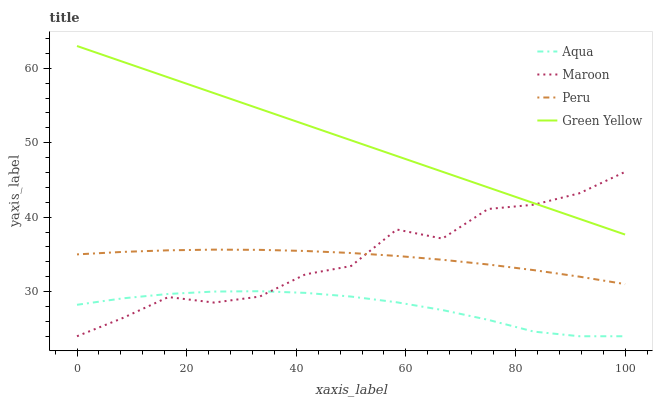Does Aqua have the minimum area under the curve?
Answer yes or no. Yes. Does Green Yellow have the maximum area under the curve?
Answer yes or no. Yes. Does Peru have the minimum area under the curve?
Answer yes or no. No. Does Peru have the maximum area under the curve?
Answer yes or no. No. Is Green Yellow the smoothest?
Answer yes or no. Yes. Is Maroon the roughest?
Answer yes or no. Yes. Is Aqua the smoothest?
Answer yes or no. No. Is Aqua the roughest?
Answer yes or no. No. Does Aqua have the lowest value?
Answer yes or no. Yes. Does Peru have the lowest value?
Answer yes or no. No. Does Green Yellow have the highest value?
Answer yes or no. Yes. Does Peru have the highest value?
Answer yes or no. No. Is Aqua less than Green Yellow?
Answer yes or no. Yes. Is Green Yellow greater than Aqua?
Answer yes or no. Yes. Does Peru intersect Maroon?
Answer yes or no. Yes. Is Peru less than Maroon?
Answer yes or no. No. Is Peru greater than Maroon?
Answer yes or no. No. Does Aqua intersect Green Yellow?
Answer yes or no. No. 